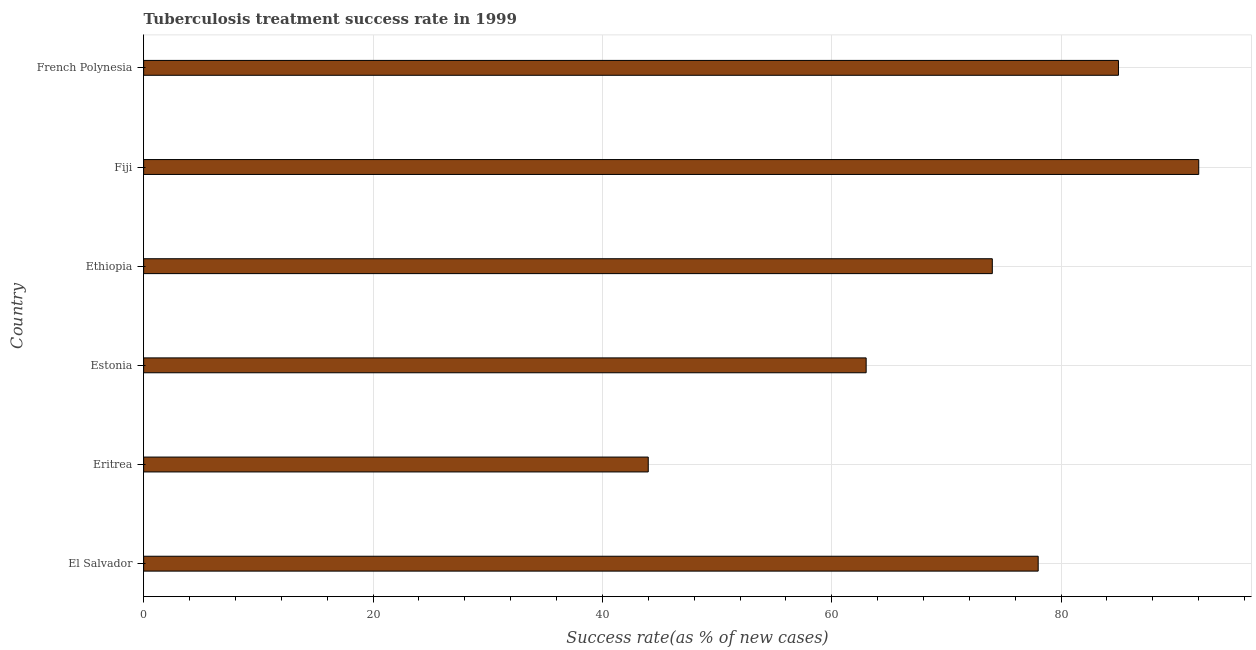What is the title of the graph?
Your answer should be compact. Tuberculosis treatment success rate in 1999. What is the label or title of the X-axis?
Keep it short and to the point. Success rate(as % of new cases). What is the label or title of the Y-axis?
Provide a short and direct response. Country. What is the tuberculosis treatment success rate in El Salvador?
Ensure brevity in your answer.  78. Across all countries, what is the maximum tuberculosis treatment success rate?
Provide a succinct answer. 92. In which country was the tuberculosis treatment success rate maximum?
Your answer should be very brief. Fiji. In which country was the tuberculosis treatment success rate minimum?
Provide a succinct answer. Eritrea. What is the sum of the tuberculosis treatment success rate?
Offer a very short reply. 436. What is the difference between the tuberculosis treatment success rate in Estonia and Ethiopia?
Ensure brevity in your answer.  -11. What is the average tuberculosis treatment success rate per country?
Your answer should be very brief. 72. In how many countries, is the tuberculosis treatment success rate greater than 76 %?
Provide a short and direct response. 3. What is the ratio of the tuberculosis treatment success rate in Estonia to that in Ethiopia?
Your answer should be compact. 0.85. Are all the bars in the graph horizontal?
Your answer should be compact. Yes. How many countries are there in the graph?
Your answer should be very brief. 6. Are the values on the major ticks of X-axis written in scientific E-notation?
Give a very brief answer. No. What is the Success rate(as % of new cases) of Eritrea?
Your answer should be compact. 44. What is the Success rate(as % of new cases) of Ethiopia?
Make the answer very short. 74. What is the Success rate(as % of new cases) in Fiji?
Your response must be concise. 92. What is the difference between the Success rate(as % of new cases) in El Salvador and Eritrea?
Provide a succinct answer. 34. What is the difference between the Success rate(as % of new cases) in El Salvador and Estonia?
Provide a succinct answer. 15. What is the difference between the Success rate(as % of new cases) in El Salvador and Ethiopia?
Make the answer very short. 4. What is the difference between the Success rate(as % of new cases) in El Salvador and French Polynesia?
Give a very brief answer. -7. What is the difference between the Success rate(as % of new cases) in Eritrea and Estonia?
Give a very brief answer. -19. What is the difference between the Success rate(as % of new cases) in Eritrea and Ethiopia?
Your answer should be compact. -30. What is the difference between the Success rate(as % of new cases) in Eritrea and Fiji?
Provide a succinct answer. -48. What is the difference between the Success rate(as % of new cases) in Eritrea and French Polynesia?
Your answer should be very brief. -41. What is the difference between the Success rate(as % of new cases) in Fiji and French Polynesia?
Your answer should be very brief. 7. What is the ratio of the Success rate(as % of new cases) in El Salvador to that in Eritrea?
Offer a terse response. 1.77. What is the ratio of the Success rate(as % of new cases) in El Salvador to that in Estonia?
Provide a short and direct response. 1.24. What is the ratio of the Success rate(as % of new cases) in El Salvador to that in Ethiopia?
Provide a succinct answer. 1.05. What is the ratio of the Success rate(as % of new cases) in El Salvador to that in Fiji?
Offer a very short reply. 0.85. What is the ratio of the Success rate(as % of new cases) in El Salvador to that in French Polynesia?
Offer a very short reply. 0.92. What is the ratio of the Success rate(as % of new cases) in Eritrea to that in Estonia?
Offer a terse response. 0.7. What is the ratio of the Success rate(as % of new cases) in Eritrea to that in Ethiopia?
Your response must be concise. 0.59. What is the ratio of the Success rate(as % of new cases) in Eritrea to that in Fiji?
Provide a succinct answer. 0.48. What is the ratio of the Success rate(as % of new cases) in Eritrea to that in French Polynesia?
Your answer should be very brief. 0.52. What is the ratio of the Success rate(as % of new cases) in Estonia to that in Ethiopia?
Offer a very short reply. 0.85. What is the ratio of the Success rate(as % of new cases) in Estonia to that in Fiji?
Give a very brief answer. 0.69. What is the ratio of the Success rate(as % of new cases) in Estonia to that in French Polynesia?
Provide a short and direct response. 0.74. What is the ratio of the Success rate(as % of new cases) in Ethiopia to that in Fiji?
Give a very brief answer. 0.8. What is the ratio of the Success rate(as % of new cases) in Ethiopia to that in French Polynesia?
Offer a terse response. 0.87. What is the ratio of the Success rate(as % of new cases) in Fiji to that in French Polynesia?
Ensure brevity in your answer.  1.08. 